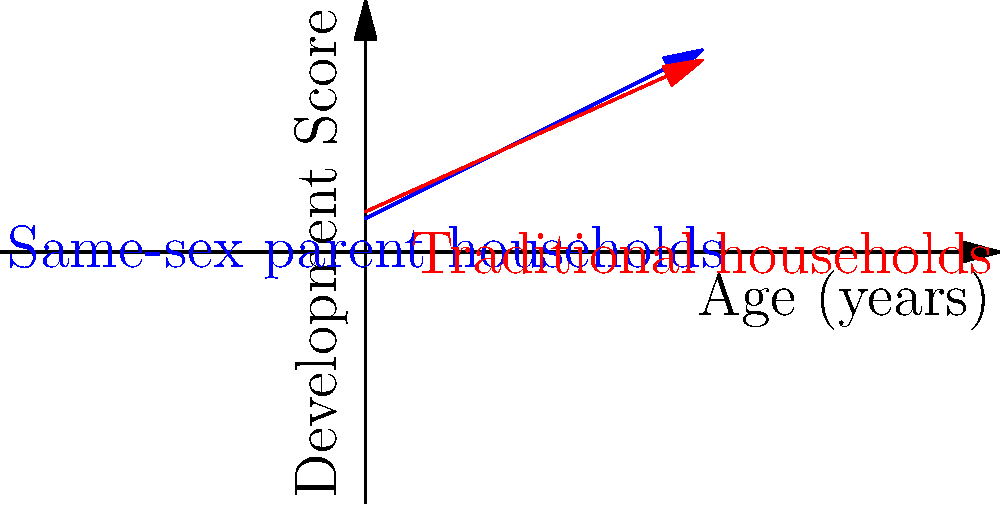Based on the graph, which shows the development trajectories of children in same-sex parent households (blue) and traditional households (red), what can be concluded about the growth patterns of children in these two family structures? To analyze the growth trajectories shown in the graph, we need to consider several aspects:

1. Starting points: The blue line (same-sex parent households) starts slightly lower than the red line (traditional households) at age 0.

2. Slope of the lines: The blue line has a steeper slope compared to the red line.

3. Intersection point: The two lines intersect at approximately age 4-5 years.

4. Long-term trajectory: After the intersection point, the blue line continues above the red line.

Step-by-step analysis:
1. At the beginning (age 0), children in traditional households start with a slightly higher development score.
2. The steeper slope of the blue line indicates that children in same-sex parent households show a faster rate of development.
3. Around age 4-5, the development scores for both groups are equal.
4. Beyond this point, children in same-sex parent households continue to show higher development scores.

This graph suggests that while children in same-sex parent households may start with slightly lower development scores, they exhibit a faster rate of development and eventually surpass their peers from traditional households in terms of overall development scores.
Answer: Children in same-sex parent households show initially lower but faster and eventually higher developmental trajectories compared to those in traditional households. 